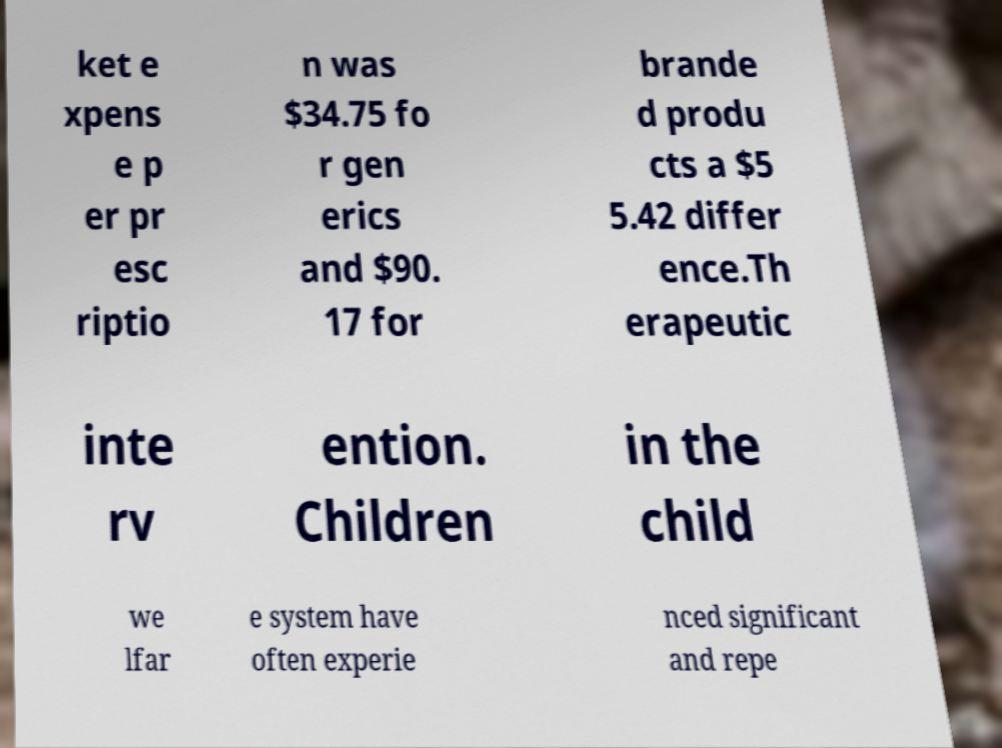For documentation purposes, I need the text within this image transcribed. Could you provide that? ket e xpens e p er pr esc riptio n was $34.75 fo r gen erics and $90. 17 for brande d produ cts a $5 5.42 differ ence.Th erapeutic inte rv ention. Children in the child we lfar e system have often experie nced significant and repe 